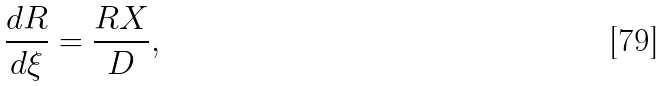<formula> <loc_0><loc_0><loc_500><loc_500>\frac { d R } { d \xi } = \frac { R X } { D } ,</formula> 